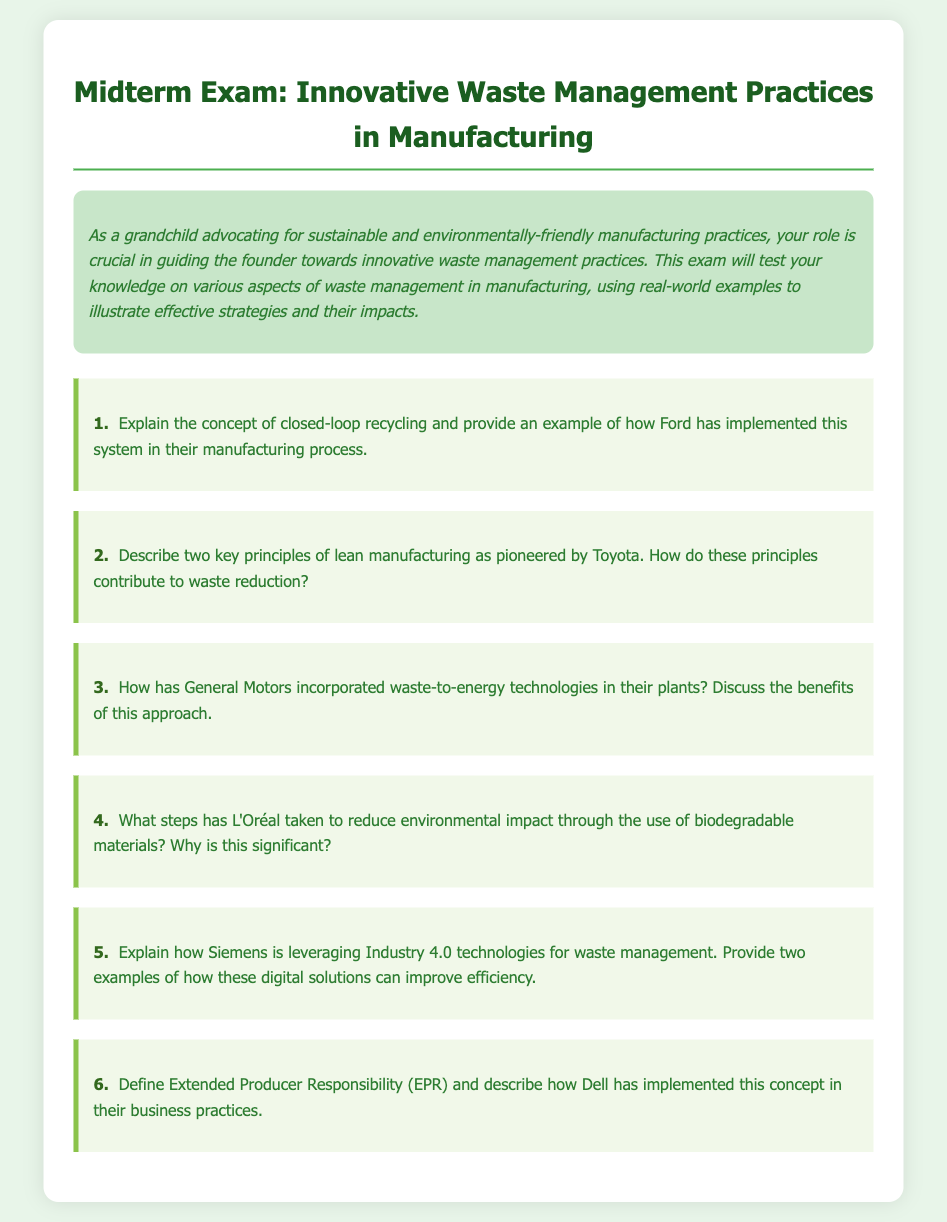What is the title of the document? The title of the document is indicated on the top and is "Innovative Waste Management Practices in Manufacturing."
Answer: Innovative Waste Management Practices in Manufacturing Who is the intended audience for this midterm exam? The intended audience is outlined in the introduction, specifically mentioning a grandchild advocating for sustainable practices.
Answer: Grandchild What is the color of the body background in the document? The color of the body background is specified in the CSS styles as light green.
Answer: #e8f5e9 How many questions does the exam contain? The exam contains a total of six questions, as outlined in the document structure.
Answer: 6 What manufacturing practices has L'Oréal focused on to reduce environmental impact? The question specifically mentions L'Oréal's efforts through biodegradable materials.
Answer: Biodegradable materials What concept does the term 'Extended Producer Responsibility' refer to? This term is specifically defined in the document concerning Dell's implementation in their business practices.
Answer: Extended Producer Responsibility 